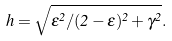Convert formula to latex. <formula><loc_0><loc_0><loc_500><loc_500>h = \sqrt { \epsilon ^ { 2 } / ( 2 - \epsilon ) ^ { 2 } + \gamma ^ { 2 } } .</formula> 